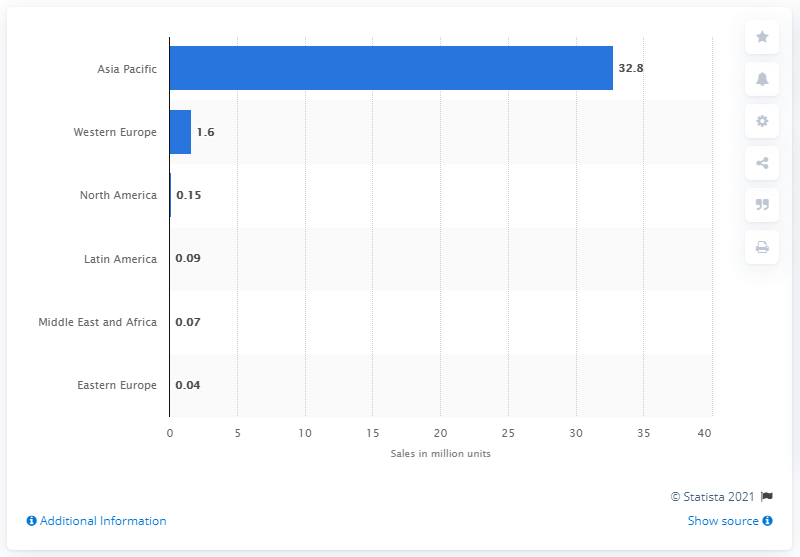Give some essential details in this illustration. In 2016, a total of 32,800 electric bikes were sold in the Asia-Pacific region. 